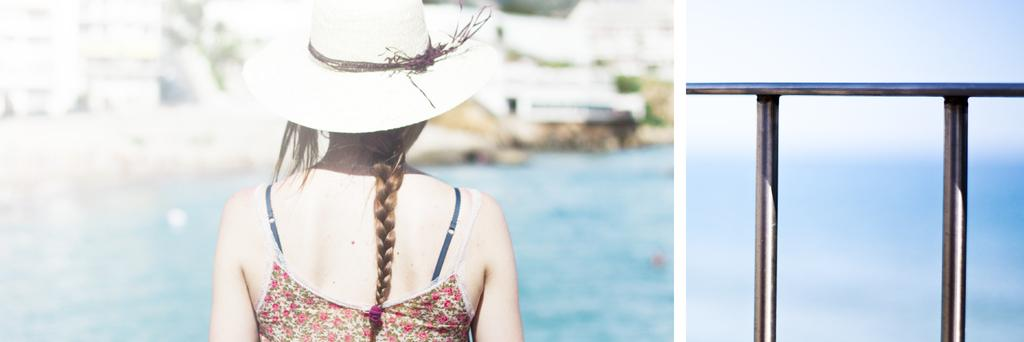Who is the main subject in the image? There is a girl in the image. What is the girl wearing on her head? The girl is wearing a hat. What can be seen on the right side of the image? There is a handrail on the right side of the image. How would you describe the background of the image? The background of the image is blurred. What is present at the bottom of the image? There appears to be water at the bottom of the image. What type of flesh can be seen on the chair in the image? There is no chair or flesh present in the image. 